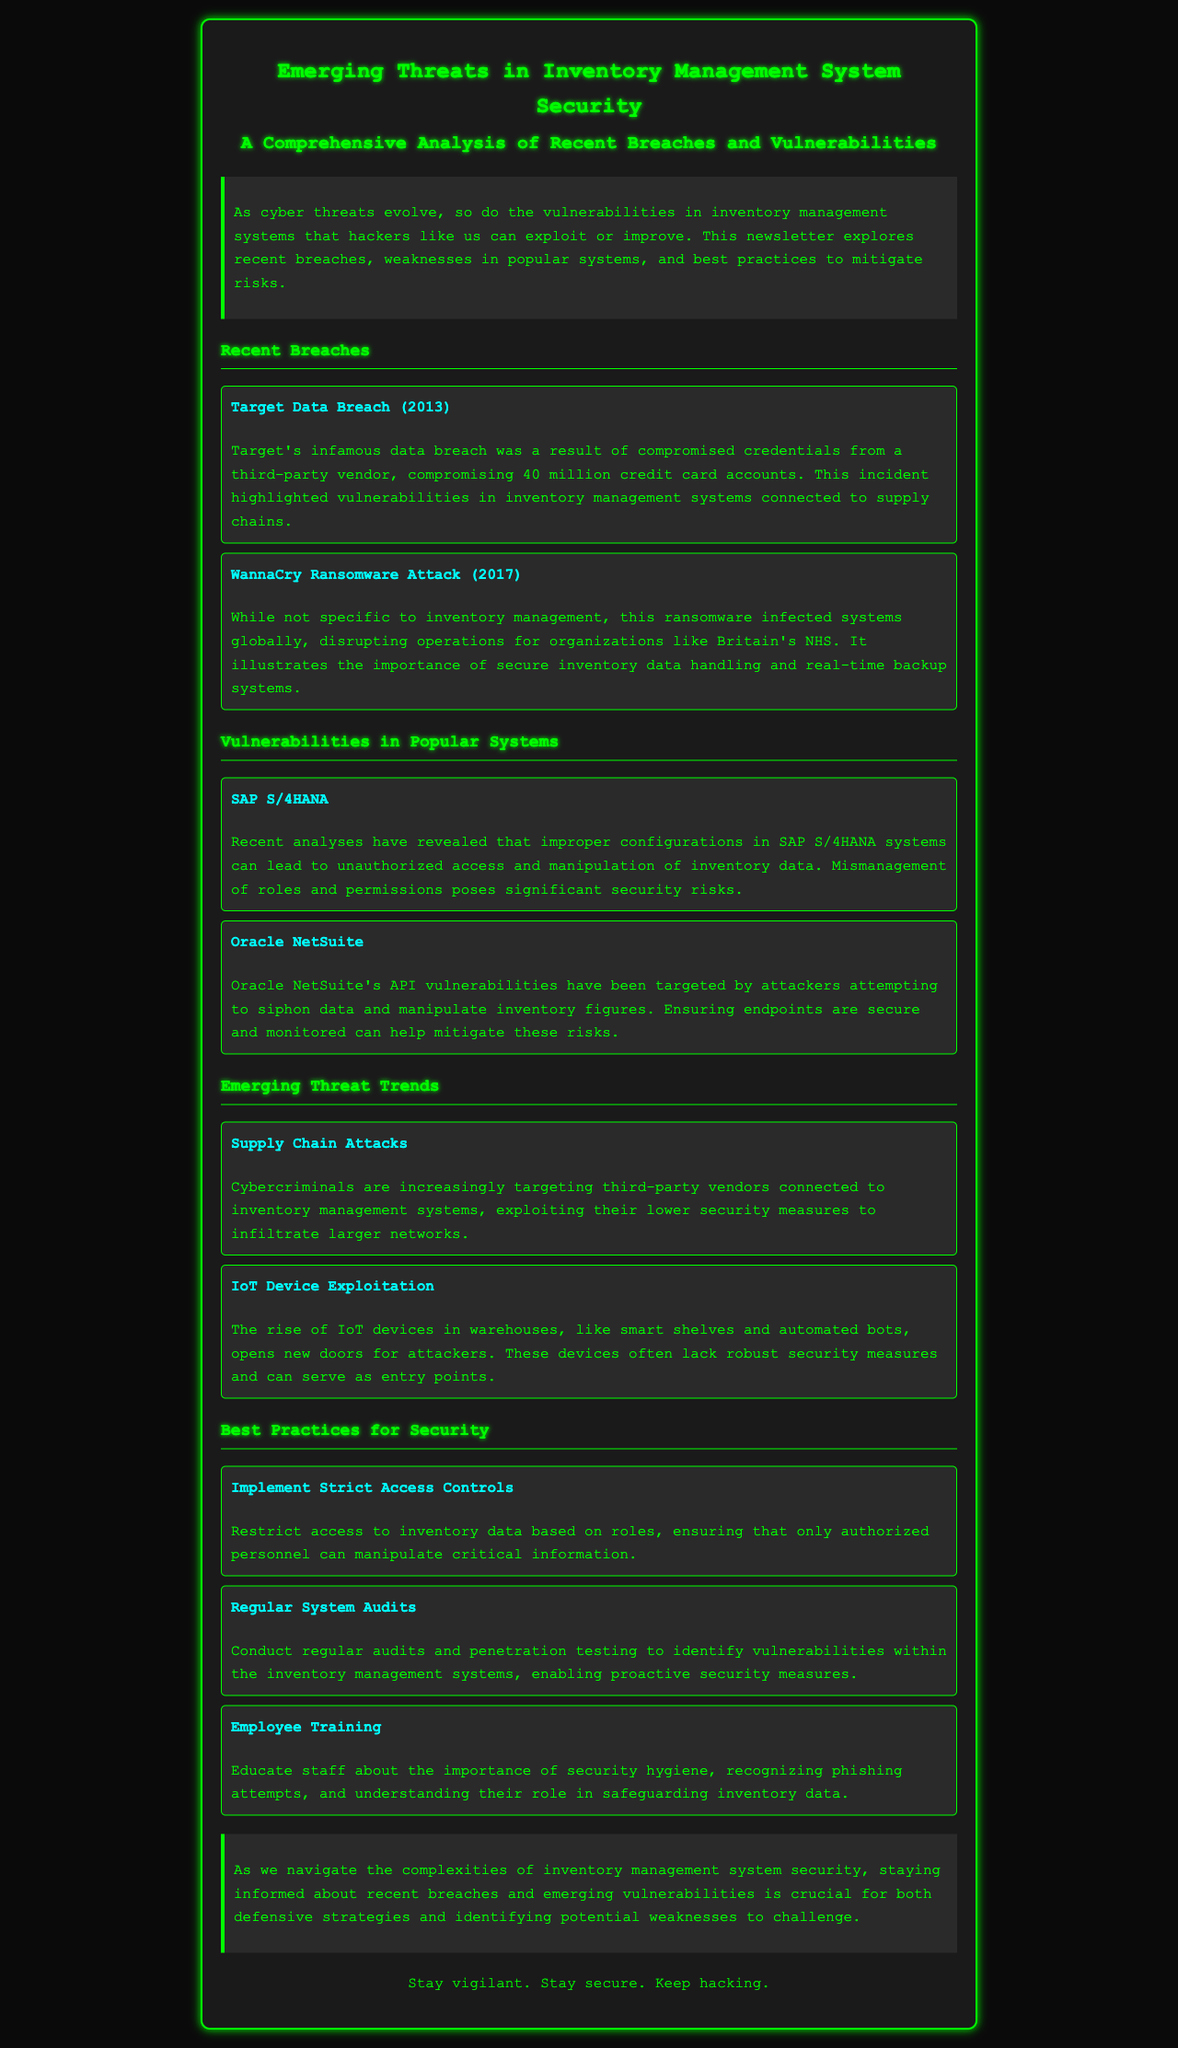What was compromised during the Target Data Breach? The Target Data Breach compromised 40 million credit card accounts due to compromised credentials from a third-party vendor.
Answer: 40 million credit card accounts What major ransomware attack affected the NHS in 2017? The WannaCry Ransomware Attack disrupted operations for organizations including Britain's NHS in 2017.
Answer: WannaCry Ransomware Attack What security risk is associated with SAP S/4HANA systems? In SAP S/4HANA systems, improper configurations can lead to unauthorized access and manipulation of inventory data.
Answer: Unauthorized access What is a primary security concern with Oracle NetSuite? Oracle NetSuite's API vulnerabilities allow attackers to siphon data and manipulate inventory figures.
Answer: API vulnerabilities According to the document, what type of attacks are increasingly targeting third-party vendors? Cybercriminals are increasingly targeting third-party vendors connected to inventory management systems through supply chain attacks.
Answer: Supply Chain Attacks What security measure is recommended to manage inventory data access? It is recommended to implement strict access controls to ensure only authorized personnel can manipulate inventory data.
Answer: Strict access controls How should vulnerabilities within inventory management systems be identified? Regular system audits and penetration testing should be conducted to identify vulnerabilities in inventory management systems.
Answer: Regular system audits What role does employee training play in inventory management security? Employee training educates staff about security hygiene, phishing recognition, and safeguarding inventory data.
Answer: Security hygiene What type of document is this? The document is a newsletter that analyses emerging threats in inventory management system security.
Answer: Newsletter 